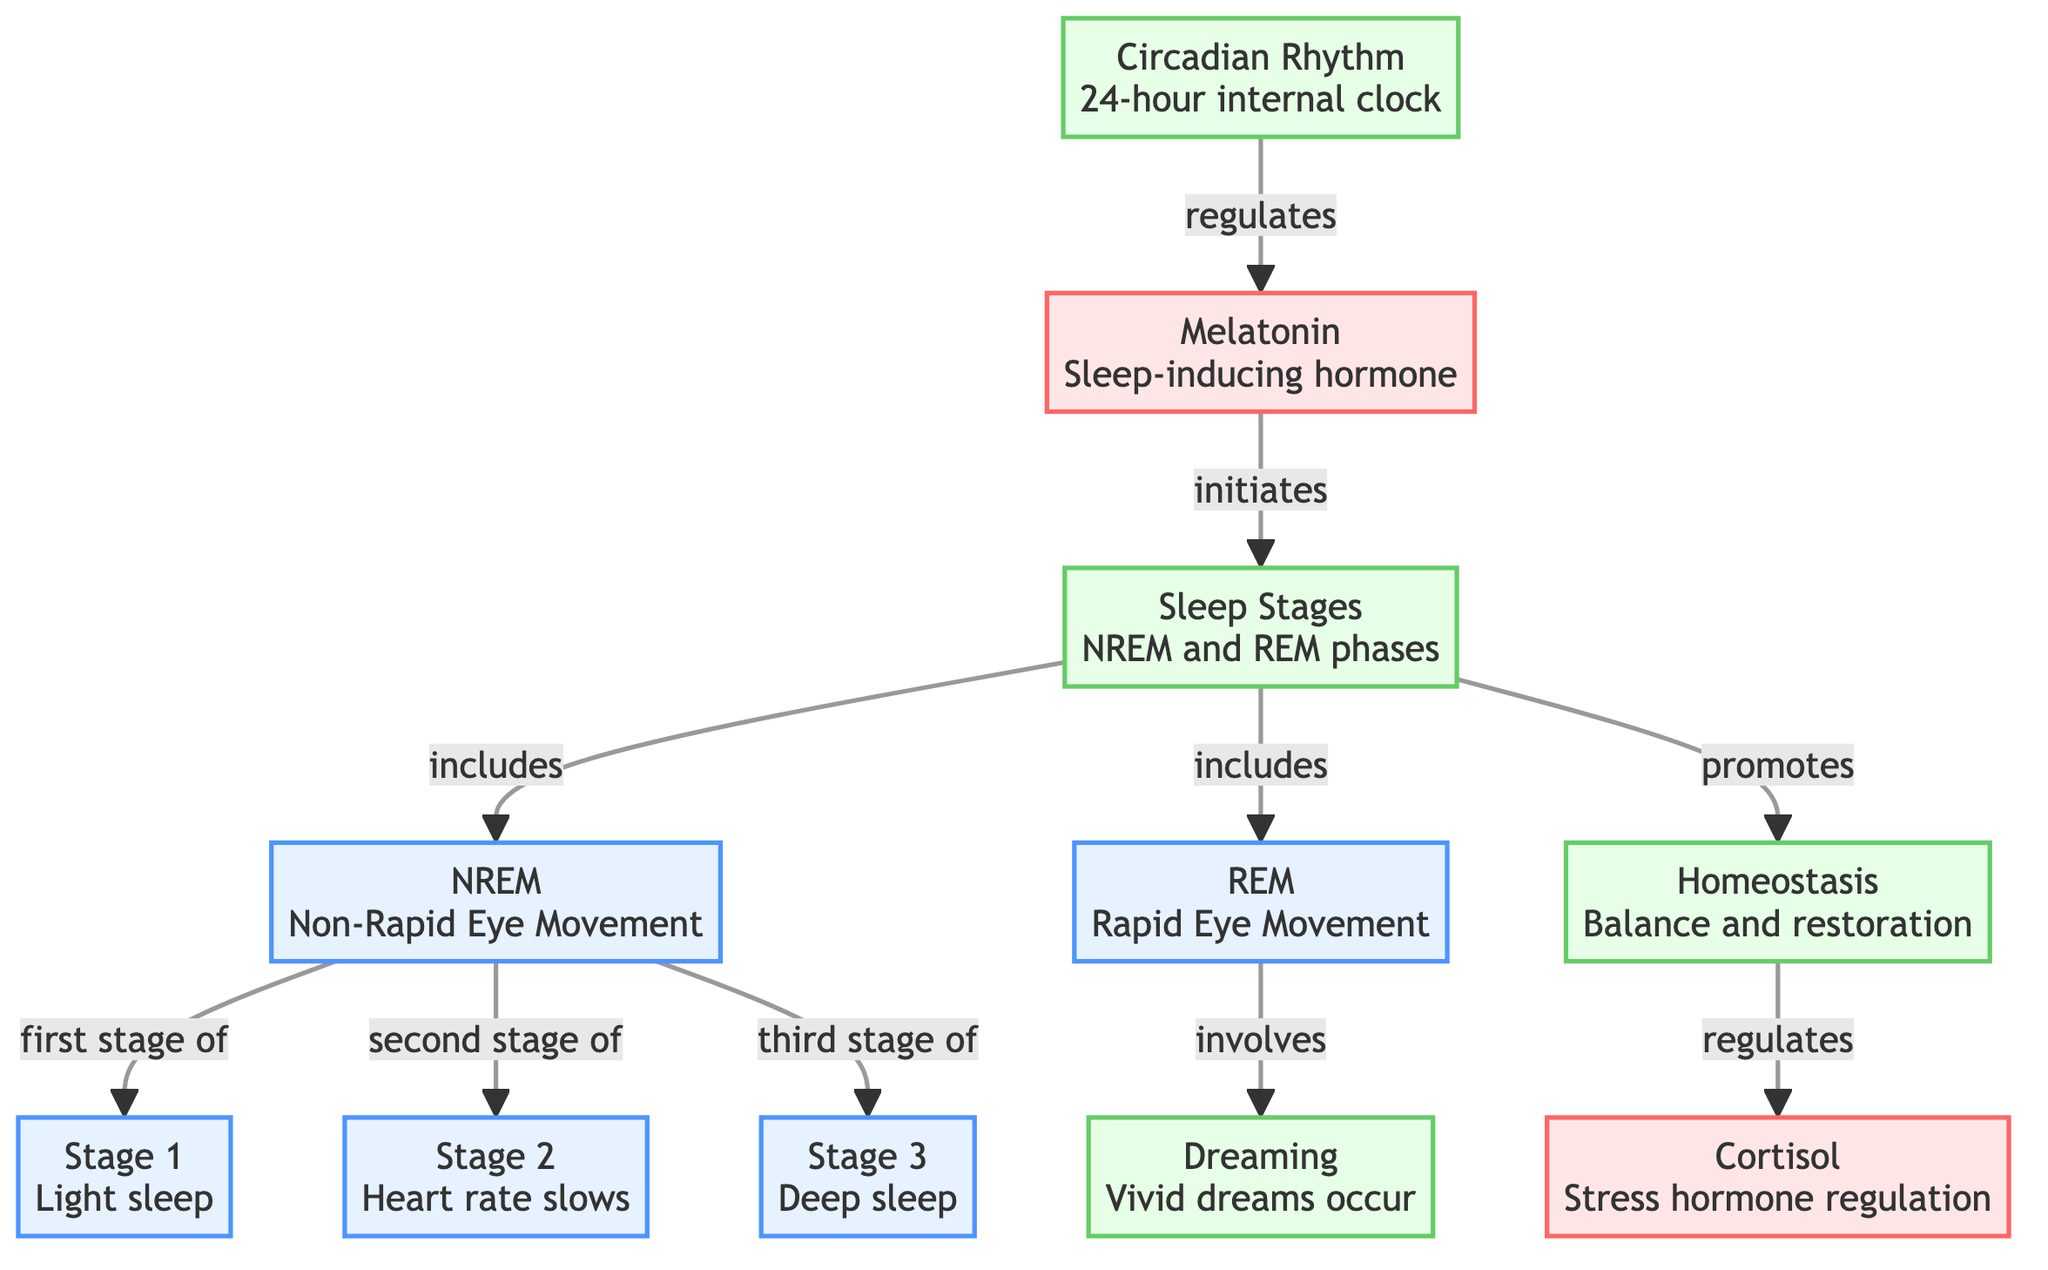What does the Circadian Rhythm regulate? The diagram shows an arrow pointing from the Circadian Rhythm to the Melatonin hormone, indicating that it regulates this hormone.
Answer: Melatonin How many stages are there in NREM sleep? The NREM node points to three stages: Stage 1, Stage 2, and Stage 3. Counting these, we see there are three stages.
Answer: 3 Which hormone is known for stress regulation? The diagram indicates that Cortisol is associated with the regulation of stress, as it is connected to the Homeostasis process.
Answer: Cortisol What initiates the sleep phases? The diagram shows an arrow leading from Melatonin to Sleep Stages, indicating that Melatonin is responsible for initiating these phases.
Answer: Melatonin What phase includes vivid dreams? The arrow from REM points to Dreaming, indicating that this phase includes vivid dreams during sleep.
Answer: REM What is the relationship between Homeostasis and Cortisol? The Homeostasis node has an arrow leading to Cortisol, indicating that Homeostasis regulates this hormone within the sleep cycle.
Answer: regulates What are the two main types of sleep phases depicted? The diagram shows arrows leading from Sleep Stages node to NREM and REM phases, indicating these are the two main types.
Answer: NREM and REM What happens during Stage 2 of sleep? The diagram specifies that in Stage 2, the heart rate slows down, which is the main characteristic of this stage.
Answer: Heart rate slows Which phase is characterized as deep sleep? The third stage of NREM sleep, as indicated in the diagram, is where deep sleep occurs.
Answer: Stage 3 